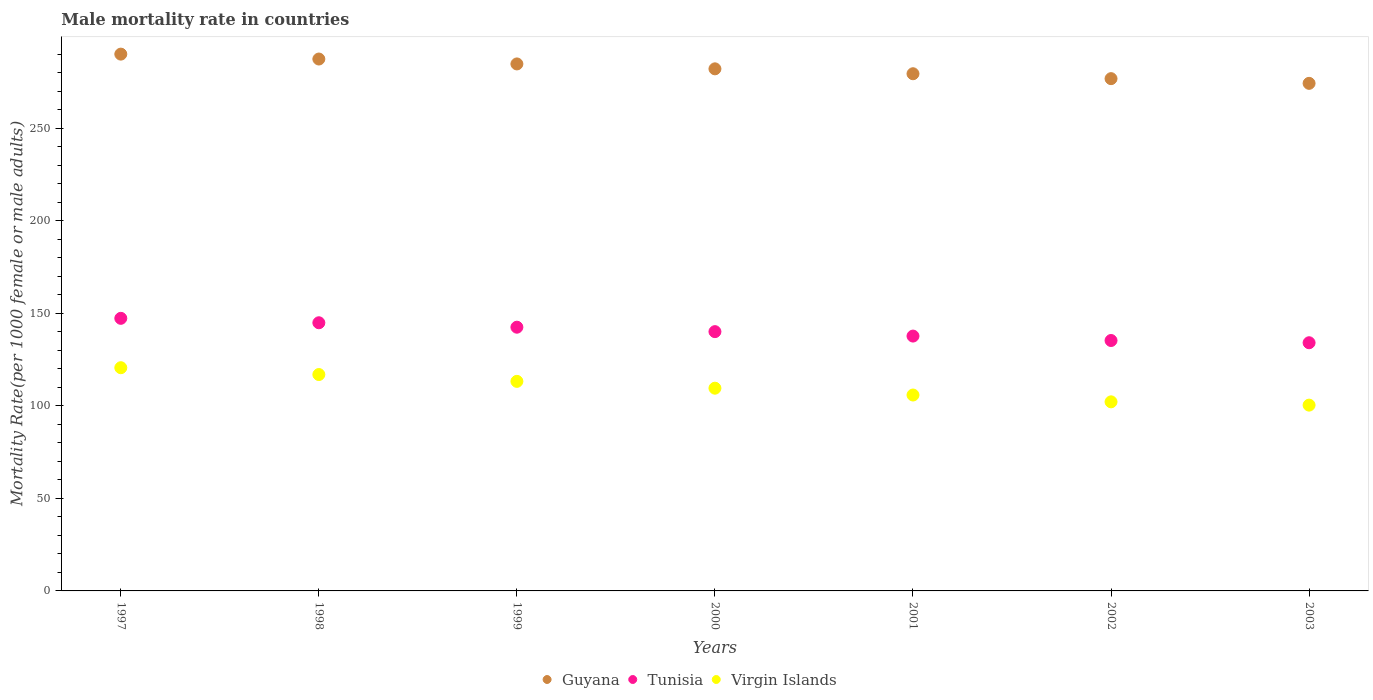How many different coloured dotlines are there?
Your answer should be compact. 3. What is the male mortality rate in Tunisia in 2001?
Give a very brief answer. 137.74. Across all years, what is the maximum male mortality rate in Guyana?
Keep it short and to the point. 290.13. Across all years, what is the minimum male mortality rate in Virgin Islands?
Ensure brevity in your answer.  100.42. What is the total male mortality rate in Guyana in the graph?
Keep it short and to the point. 1975.35. What is the difference between the male mortality rate in Virgin Islands in 2001 and that in 2002?
Make the answer very short. 3.69. What is the difference between the male mortality rate in Virgin Islands in 2002 and the male mortality rate in Tunisia in 1999?
Your answer should be compact. -40.34. What is the average male mortality rate in Virgin Islands per year?
Provide a short and direct response. 109.85. In the year 2000, what is the difference between the male mortality rate in Virgin Islands and male mortality rate in Guyana?
Keep it short and to the point. -172.6. What is the ratio of the male mortality rate in Tunisia in 1997 to that in 1999?
Give a very brief answer. 1.03. Is the male mortality rate in Virgin Islands in 2000 less than that in 2002?
Your response must be concise. No. Is the difference between the male mortality rate in Virgin Islands in 1997 and 1998 greater than the difference between the male mortality rate in Guyana in 1997 and 1998?
Ensure brevity in your answer.  Yes. What is the difference between the highest and the second highest male mortality rate in Tunisia?
Provide a short and direct response. 2.4. What is the difference between the highest and the lowest male mortality rate in Virgin Islands?
Offer a very short reply. 20.22. Is the male mortality rate in Tunisia strictly greater than the male mortality rate in Virgin Islands over the years?
Your response must be concise. Yes. Where does the legend appear in the graph?
Your response must be concise. Bottom center. What is the title of the graph?
Give a very brief answer. Male mortality rate in countries. What is the label or title of the X-axis?
Provide a succinct answer. Years. What is the label or title of the Y-axis?
Ensure brevity in your answer.  Mortality Rate(per 1000 female or male adults). What is the Mortality Rate(per 1000 female or male adults) of Guyana in 1997?
Keep it short and to the point. 290.13. What is the Mortality Rate(per 1000 female or male adults) of Tunisia in 1997?
Your response must be concise. 147.33. What is the Mortality Rate(per 1000 female or male adults) in Virgin Islands in 1997?
Keep it short and to the point. 120.64. What is the Mortality Rate(per 1000 female or male adults) in Guyana in 1998?
Your response must be concise. 287.48. What is the Mortality Rate(per 1000 female or male adults) in Tunisia in 1998?
Make the answer very short. 144.93. What is the Mortality Rate(per 1000 female or male adults) of Virgin Islands in 1998?
Keep it short and to the point. 116.95. What is the Mortality Rate(per 1000 female or male adults) in Guyana in 1999?
Your answer should be very brief. 284.83. What is the Mortality Rate(per 1000 female or male adults) in Tunisia in 1999?
Give a very brief answer. 142.54. What is the Mortality Rate(per 1000 female or male adults) in Virgin Islands in 1999?
Provide a short and direct response. 113.26. What is the Mortality Rate(per 1000 female or male adults) in Guyana in 2000?
Keep it short and to the point. 282.18. What is the Mortality Rate(per 1000 female or male adults) of Tunisia in 2000?
Offer a very short reply. 140.14. What is the Mortality Rate(per 1000 female or male adults) of Virgin Islands in 2000?
Your answer should be compact. 109.57. What is the Mortality Rate(per 1000 female or male adults) of Guyana in 2001?
Offer a terse response. 279.53. What is the Mortality Rate(per 1000 female or male adults) in Tunisia in 2001?
Your answer should be very brief. 137.74. What is the Mortality Rate(per 1000 female or male adults) of Virgin Islands in 2001?
Keep it short and to the point. 105.88. What is the Mortality Rate(per 1000 female or male adults) of Guyana in 2002?
Provide a succinct answer. 276.88. What is the Mortality Rate(per 1000 female or male adults) in Tunisia in 2002?
Offer a terse response. 135.34. What is the Mortality Rate(per 1000 female or male adults) in Virgin Islands in 2002?
Give a very brief answer. 102.19. What is the Mortality Rate(per 1000 female or male adults) of Guyana in 2003?
Your response must be concise. 274.34. What is the Mortality Rate(per 1000 female or male adults) in Tunisia in 2003?
Offer a very short reply. 134.13. What is the Mortality Rate(per 1000 female or male adults) in Virgin Islands in 2003?
Provide a succinct answer. 100.42. Across all years, what is the maximum Mortality Rate(per 1000 female or male adults) in Guyana?
Your answer should be very brief. 290.13. Across all years, what is the maximum Mortality Rate(per 1000 female or male adults) of Tunisia?
Give a very brief answer. 147.33. Across all years, what is the maximum Mortality Rate(per 1000 female or male adults) of Virgin Islands?
Make the answer very short. 120.64. Across all years, what is the minimum Mortality Rate(per 1000 female or male adults) in Guyana?
Your response must be concise. 274.34. Across all years, what is the minimum Mortality Rate(per 1000 female or male adults) of Tunisia?
Give a very brief answer. 134.13. Across all years, what is the minimum Mortality Rate(per 1000 female or male adults) of Virgin Islands?
Provide a succinct answer. 100.42. What is the total Mortality Rate(per 1000 female or male adults) in Guyana in the graph?
Provide a short and direct response. 1975.35. What is the total Mortality Rate(per 1000 female or male adults) in Tunisia in the graph?
Offer a terse response. 982.16. What is the total Mortality Rate(per 1000 female or male adults) of Virgin Islands in the graph?
Offer a very short reply. 768.92. What is the difference between the Mortality Rate(per 1000 female or male adults) of Guyana in 1997 and that in 1998?
Offer a terse response. 2.65. What is the difference between the Mortality Rate(per 1000 female or male adults) in Tunisia in 1997 and that in 1998?
Your answer should be compact. 2.4. What is the difference between the Mortality Rate(per 1000 female or male adults) of Virgin Islands in 1997 and that in 1998?
Offer a very short reply. 3.69. What is the difference between the Mortality Rate(per 1000 female or male adults) in Guyana in 1997 and that in 1999?
Offer a very short reply. 5.3. What is the difference between the Mortality Rate(per 1000 female or male adults) in Tunisia in 1997 and that in 1999?
Give a very brief answer. 4.8. What is the difference between the Mortality Rate(per 1000 female or male adults) of Virgin Islands in 1997 and that in 1999?
Give a very brief answer. 7.38. What is the difference between the Mortality Rate(per 1000 female or male adults) in Guyana in 1997 and that in 2000?
Provide a short and direct response. 7.95. What is the difference between the Mortality Rate(per 1000 female or male adults) of Tunisia in 1997 and that in 2000?
Offer a very short reply. 7.19. What is the difference between the Mortality Rate(per 1000 female or male adults) in Virgin Islands in 1997 and that in 2000?
Make the answer very short. 11.07. What is the difference between the Mortality Rate(per 1000 female or male adults) of Guyana in 1997 and that in 2001?
Ensure brevity in your answer.  10.6. What is the difference between the Mortality Rate(per 1000 female or male adults) in Tunisia in 1997 and that in 2001?
Your answer should be very brief. 9.59. What is the difference between the Mortality Rate(per 1000 female or male adults) of Virgin Islands in 1997 and that in 2001?
Make the answer very short. 14.76. What is the difference between the Mortality Rate(per 1000 female or male adults) of Guyana in 1997 and that in 2002?
Make the answer very short. 13.26. What is the difference between the Mortality Rate(per 1000 female or male adults) in Tunisia in 1997 and that in 2002?
Give a very brief answer. 11.99. What is the difference between the Mortality Rate(per 1000 female or male adults) of Virgin Islands in 1997 and that in 2002?
Offer a terse response. 18.45. What is the difference between the Mortality Rate(per 1000 female or male adults) in Guyana in 1997 and that in 2003?
Offer a very short reply. 15.79. What is the difference between the Mortality Rate(per 1000 female or male adults) in Tunisia in 1997 and that in 2003?
Give a very brief answer. 13.2. What is the difference between the Mortality Rate(per 1000 female or male adults) in Virgin Islands in 1997 and that in 2003?
Make the answer very short. 20.22. What is the difference between the Mortality Rate(per 1000 female or male adults) in Guyana in 1998 and that in 1999?
Your answer should be very brief. 2.65. What is the difference between the Mortality Rate(per 1000 female or male adults) in Tunisia in 1998 and that in 1999?
Offer a very short reply. 2.4. What is the difference between the Mortality Rate(per 1000 female or male adults) of Virgin Islands in 1998 and that in 1999?
Your answer should be compact. 3.69. What is the difference between the Mortality Rate(per 1000 female or male adults) of Guyana in 1998 and that in 2000?
Make the answer very short. 5.3. What is the difference between the Mortality Rate(per 1000 female or male adults) in Tunisia in 1998 and that in 2000?
Keep it short and to the point. 4.8. What is the difference between the Mortality Rate(per 1000 female or male adults) in Virgin Islands in 1998 and that in 2000?
Give a very brief answer. 7.38. What is the difference between the Mortality Rate(per 1000 female or male adults) in Guyana in 1998 and that in 2001?
Offer a very short reply. 7.95. What is the difference between the Mortality Rate(per 1000 female or male adults) in Tunisia in 1998 and that in 2001?
Keep it short and to the point. 7.19. What is the difference between the Mortality Rate(per 1000 female or male adults) of Virgin Islands in 1998 and that in 2001?
Offer a very short reply. 11.07. What is the difference between the Mortality Rate(per 1000 female or male adults) of Guyana in 1998 and that in 2002?
Your response must be concise. 10.6. What is the difference between the Mortality Rate(per 1000 female or male adults) in Tunisia in 1998 and that in 2002?
Provide a succinct answer. 9.59. What is the difference between the Mortality Rate(per 1000 female or male adults) in Virgin Islands in 1998 and that in 2002?
Offer a very short reply. 14.76. What is the difference between the Mortality Rate(per 1000 female or male adults) in Guyana in 1998 and that in 2003?
Your answer should be very brief. 13.14. What is the difference between the Mortality Rate(per 1000 female or male adults) in Tunisia in 1998 and that in 2003?
Provide a succinct answer. 10.8. What is the difference between the Mortality Rate(per 1000 female or male adults) of Virgin Islands in 1998 and that in 2003?
Offer a very short reply. 16.53. What is the difference between the Mortality Rate(per 1000 female or male adults) of Guyana in 1999 and that in 2000?
Keep it short and to the point. 2.65. What is the difference between the Mortality Rate(per 1000 female or male adults) in Tunisia in 1999 and that in 2000?
Your response must be concise. 2.4. What is the difference between the Mortality Rate(per 1000 female or male adults) in Virgin Islands in 1999 and that in 2000?
Provide a short and direct response. 3.69. What is the difference between the Mortality Rate(per 1000 female or male adults) in Guyana in 1999 and that in 2001?
Provide a short and direct response. 5.3. What is the difference between the Mortality Rate(per 1000 female or male adults) in Tunisia in 1999 and that in 2001?
Provide a short and direct response. 4.8. What is the difference between the Mortality Rate(per 1000 female or male adults) of Virgin Islands in 1999 and that in 2001?
Keep it short and to the point. 7.38. What is the difference between the Mortality Rate(per 1000 female or male adults) in Guyana in 1999 and that in 2002?
Keep it short and to the point. 7.95. What is the difference between the Mortality Rate(per 1000 female or male adults) of Tunisia in 1999 and that in 2002?
Your response must be concise. 7.19. What is the difference between the Mortality Rate(per 1000 female or male adults) in Virgin Islands in 1999 and that in 2002?
Give a very brief answer. 11.07. What is the difference between the Mortality Rate(per 1000 female or male adults) in Guyana in 1999 and that in 2003?
Offer a very short reply. 10.49. What is the difference between the Mortality Rate(per 1000 female or male adults) of Tunisia in 1999 and that in 2003?
Provide a succinct answer. 8.4. What is the difference between the Mortality Rate(per 1000 female or male adults) in Virgin Islands in 1999 and that in 2003?
Make the answer very short. 12.84. What is the difference between the Mortality Rate(per 1000 female or male adults) in Guyana in 2000 and that in 2001?
Your answer should be compact. 2.65. What is the difference between the Mortality Rate(per 1000 female or male adults) in Tunisia in 2000 and that in 2001?
Offer a very short reply. 2.4. What is the difference between the Mortality Rate(per 1000 female or male adults) of Virgin Islands in 2000 and that in 2001?
Provide a succinct answer. 3.69. What is the difference between the Mortality Rate(per 1000 female or male adults) of Guyana in 2000 and that in 2002?
Provide a succinct answer. 5.3. What is the difference between the Mortality Rate(per 1000 female or male adults) in Tunisia in 2000 and that in 2002?
Offer a very short reply. 4.8. What is the difference between the Mortality Rate(per 1000 female or male adults) in Virgin Islands in 2000 and that in 2002?
Provide a short and direct response. 7.38. What is the difference between the Mortality Rate(per 1000 female or male adults) in Guyana in 2000 and that in 2003?
Ensure brevity in your answer.  7.84. What is the difference between the Mortality Rate(per 1000 female or male adults) of Tunisia in 2000 and that in 2003?
Make the answer very short. 6. What is the difference between the Mortality Rate(per 1000 female or male adults) of Virgin Islands in 2000 and that in 2003?
Your response must be concise. 9.15. What is the difference between the Mortality Rate(per 1000 female or male adults) of Guyana in 2001 and that in 2002?
Make the answer very short. 2.65. What is the difference between the Mortality Rate(per 1000 female or male adults) in Tunisia in 2001 and that in 2002?
Give a very brief answer. 2.4. What is the difference between the Mortality Rate(per 1000 female or male adults) of Virgin Islands in 2001 and that in 2002?
Your answer should be compact. 3.69. What is the difference between the Mortality Rate(per 1000 female or male adults) in Guyana in 2001 and that in 2003?
Give a very brief answer. 5.19. What is the difference between the Mortality Rate(per 1000 female or male adults) of Tunisia in 2001 and that in 2003?
Offer a terse response. 3.61. What is the difference between the Mortality Rate(per 1000 female or male adults) in Virgin Islands in 2001 and that in 2003?
Your answer should be compact. 5.46. What is the difference between the Mortality Rate(per 1000 female or male adults) of Guyana in 2002 and that in 2003?
Offer a very short reply. 2.54. What is the difference between the Mortality Rate(per 1000 female or male adults) of Tunisia in 2002 and that in 2003?
Offer a very short reply. 1.21. What is the difference between the Mortality Rate(per 1000 female or male adults) of Virgin Islands in 2002 and that in 2003?
Ensure brevity in your answer.  1.77. What is the difference between the Mortality Rate(per 1000 female or male adults) of Guyana in 1997 and the Mortality Rate(per 1000 female or male adults) of Tunisia in 1998?
Your answer should be compact. 145.2. What is the difference between the Mortality Rate(per 1000 female or male adults) of Guyana in 1997 and the Mortality Rate(per 1000 female or male adults) of Virgin Islands in 1998?
Your answer should be very brief. 173.18. What is the difference between the Mortality Rate(per 1000 female or male adults) of Tunisia in 1997 and the Mortality Rate(per 1000 female or male adults) of Virgin Islands in 1998?
Your response must be concise. 30.38. What is the difference between the Mortality Rate(per 1000 female or male adults) in Guyana in 1997 and the Mortality Rate(per 1000 female or male adults) in Tunisia in 1999?
Provide a succinct answer. 147.59. What is the difference between the Mortality Rate(per 1000 female or male adults) in Guyana in 1997 and the Mortality Rate(per 1000 female or male adults) in Virgin Islands in 1999?
Keep it short and to the point. 176.87. What is the difference between the Mortality Rate(per 1000 female or male adults) of Tunisia in 1997 and the Mortality Rate(per 1000 female or male adults) of Virgin Islands in 1999?
Ensure brevity in your answer.  34.07. What is the difference between the Mortality Rate(per 1000 female or male adults) in Guyana in 1997 and the Mortality Rate(per 1000 female or male adults) in Tunisia in 2000?
Provide a short and direct response. 149.99. What is the difference between the Mortality Rate(per 1000 female or male adults) in Guyana in 1997 and the Mortality Rate(per 1000 female or male adults) in Virgin Islands in 2000?
Keep it short and to the point. 180.56. What is the difference between the Mortality Rate(per 1000 female or male adults) in Tunisia in 1997 and the Mortality Rate(per 1000 female or male adults) in Virgin Islands in 2000?
Give a very brief answer. 37.76. What is the difference between the Mortality Rate(per 1000 female or male adults) in Guyana in 1997 and the Mortality Rate(per 1000 female or male adults) in Tunisia in 2001?
Make the answer very short. 152.39. What is the difference between the Mortality Rate(per 1000 female or male adults) in Guyana in 1997 and the Mortality Rate(per 1000 female or male adults) in Virgin Islands in 2001?
Keep it short and to the point. 184.25. What is the difference between the Mortality Rate(per 1000 female or male adults) of Tunisia in 1997 and the Mortality Rate(per 1000 female or male adults) of Virgin Islands in 2001?
Provide a short and direct response. 41.45. What is the difference between the Mortality Rate(per 1000 female or male adults) in Guyana in 1997 and the Mortality Rate(per 1000 female or male adults) in Tunisia in 2002?
Ensure brevity in your answer.  154.79. What is the difference between the Mortality Rate(per 1000 female or male adults) of Guyana in 1997 and the Mortality Rate(per 1000 female or male adults) of Virgin Islands in 2002?
Make the answer very short. 187.94. What is the difference between the Mortality Rate(per 1000 female or male adults) in Tunisia in 1997 and the Mortality Rate(per 1000 female or male adults) in Virgin Islands in 2002?
Ensure brevity in your answer.  45.14. What is the difference between the Mortality Rate(per 1000 female or male adults) in Guyana in 1997 and the Mortality Rate(per 1000 female or male adults) in Tunisia in 2003?
Ensure brevity in your answer.  156. What is the difference between the Mortality Rate(per 1000 female or male adults) in Guyana in 1997 and the Mortality Rate(per 1000 female or male adults) in Virgin Islands in 2003?
Provide a succinct answer. 189.71. What is the difference between the Mortality Rate(per 1000 female or male adults) of Tunisia in 1997 and the Mortality Rate(per 1000 female or male adults) of Virgin Islands in 2003?
Give a very brief answer. 46.91. What is the difference between the Mortality Rate(per 1000 female or male adults) in Guyana in 1998 and the Mortality Rate(per 1000 female or male adults) in Tunisia in 1999?
Offer a terse response. 144.94. What is the difference between the Mortality Rate(per 1000 female or male adults) of Guyana in 1998 and the Mortality Rate(per 1000 female or male adults) of Virgin Islands in 1999?
Make the answer very short. 174.22. What is the difference between the Mortality Rate(per 1000 female or male adults) of Tunisia in 1998 and the Mortality Rate(per 1000 female or male adults) of Virgin Islands in 1999?
Offer a very short reply. 31.67. What is the difference between the Mortality Rate(per 1000 female or male adults) in Guyana in 1998 and the Mortality Rate(per 1000 female or male adults) in Tunisia in 2000?
Give a very brief answer. 147.34. What is the difference between the Mortality Rate(per 1000 female or male adults) in Guyana in 1998 and the Mortality Rate(per 1000 female or male adults) in Virgin Islands in 2000?
Provide a short and direct response. 177.91. What is the difference between the Mortality Rate(per 1000 female or male adults) of Tunisia in 1998 and the Mortality Rate(per 1000 female or male adults) of Virgin Islands in 2000?
Keep it short and to the point. 35.36. What is the difference between the Mortality Rate(per 1000 female or male adults) in Guyana in 1998 and the Mortality Rate(per 1000 female or male adults) in Tunisia in 2001?
Offer a terse response. 149.74. What is the difference between the Mortality Rate(per 1000 female or male adults) in Guyana in 1998 and the Mortality Rate(per 1000 female or male adults) in Virgin Islands in 2001?
Your answer should be compact. 181.6. What is the difference between the Mortality Rate(per 1000 female or male adults) of Tunisia in 1998 and the Mortality Rate(per 1000 female or male adults) of Virgin Islands in 2001?
Provide a succinct answer. 39.05. What is the difference between the Mortality Rate(per 1000 female or male adults) of Guyana in 1998 and the Mortality Rate(per 1000 female or male adults) of Tunisia in 2002?
Provide a succinct answer. 152.14. What is the difference between the Mortality Rate(per 1000 female or male adults) of Guyana in 1998 and the Mortality Rate(per 1000 female or male adults) of Virgin Islands in 2002?
Provide a short and direct response. 185.28. What is the difference between the Mortality Rate(per 1000 female or male adults) of Tunisia in 1998 and the Mortality Rate(per 1000 female or male adults) of Virgin Islands in 2002?
Keep it short and to the point. 42.74. What is the difference between the Mortality Rate(per 1000 female or male adults) of Guyana in 1998 and the Mortality Rate(per 1000 female or male adults) of Tunisia in 2003?
Your answer should be compact. 153.34. What is the difference between the Mortality Rate(per 1000 female or male adults) of Guyana in 1998 and the Mortality Rate(per 1000 female or male adults) of Virgin Islands in 2003?
Offer a very short reply. 187.06. What is the difference between the Mortality Rate(per 1000 female or male adults) in Tunisia in 1998 and the Mortality Rate(per 1000 female or male adults) in Virgin Islands in 2003?
Provide a succinct answer. 44.51. What is the difference between the Mortality Rate(per 1000 female or male adults) in Guyana in 1999 and the Mortality Rate(per 1000 female or male adults) in Tunisia in 2000?
Ensure brevity in your answer.  144.69. What is the difference between the Mortality Rate(per 1000 female or male adults) of Guyana in 1999 and the Mortality Rate(per 1000 female or male adults) of Virgin Islands in 2000?
Your response must be concise. 175.26. What is the difference between the Mortality Rate(per 1000 female or male adults) of Tunisia in 1999 and the Mortality Rate(per 1000 female or male adults) of Virgin Islands in 2000?
Offer a terse response. 32.96. What is the difference between the Mortality Rate(per 1000 female or male adults) in Guyana in 1999 and the Mortality Rate(per 1000 female or male adults) in Tunisia in 2001?
Offer a very short reply. 147.09. What is the difference between the Mortality Rate(per 1000 female or male adults) of Guyana in 1999 and the Mortality Rate(per 1000 female or male adults) of Virgin Islands in 2001?
Give a very brief answer. 178.94. What is the difference between the Mortality Rate(per 1000 female or male adults) of Tunisia in 1999 and the Mortality Rate(per 1000 female or male adults) of Virgin Islands in 2001?
Provide a succinct answer. 36.65. What is the difference between the Mortality Rate(per 1000 female or male adults) in Guyana in 1999 and the Mortality Rate(per 1000 female or male adults) in Tunisia in 2002?
Provide a short and direct response. 149.49. What is the difference between the Mortality Rate(per 1000 female or male adults) of Guyana in 1999 and the Mortality Rate(per 1000 female or male adults) of Virgin Islands in 2002?
Your answer should be very brief. 182.63. What is the difference between the Mortality Rate(per 1000 female or male adults) in Tunisia in 1999 and the Mortality Rate(per 1000 female or male adults) in Virgin Islands in 2002?
Make the answer very short. 40.34. What is the difference between the Mortality Rate(per 1000 female or male adults) of Guyana in 1999 and the Mortality Rate(per 1000 female or male adults) of Tunisia in 2003?
Your response must be concise. 150.69. What is the difference between the Mortality Rate(per 1000 female or male adults) in Guyana in 1999 and the Mortality Rate(per 1000 female or male adults) in Virgin Islands in 2003?
Offer a very short reply. 184.41. What is the difference between the Mortality Rate(per 1000 female or male adults) in Tunisia in 1999 and the Mortality Rate(per 1000 female or male adults) in Virgin Islands in 2003?
Your answer should be very brief. 42.12. What is the difference between the Mortality Rate(per 1000 female or male adults) of Guyana in 2000 and the Mortality Rate(per 1000 female or male adults) of Tunisia in 2001?
Offer a terse response. 144.44. What is the difference between the Mortality Rate(per 1000 female or male adults) in Guyana in 2000 and the Mortality Rate(per 1000 female or male adults) in Virgin Islands in 2001?
Provide a short and direct response. 176.29. What is the difference between the Mortality Rate(per 1000 female or male adults) in Tunisia in 2000 and the Mortality Rate(per 1000 female or male adults) in Virgin Islands in 2001?
Ensure brevity in your answer.  34.25. What is the difference between the Mortality Rate(per 1000 female or male adults) in Guyana in 2000 and the Mortality Rate(per 1000 female or male adults) in Tunisia in 2002?
Your answer should be very brief. 146.84. What is the difference between the Mortality Rate(per 1000 female or male adults) in Guyana in 2000 and the Mortality Rate(per 1000 female or male adults) in Virgin Islands in 2002?
Provide a short and direct response. 179.98. What is the difference between the Mortality Rate(per 1000 female or male adults) in Tunisia in 2000 and the Mortality Rate(per 1000 female or male adults) in Virgin Islands in 2002?
Your answer should be very brief. 37.94. What is the difference between the Mortality Rate(per 1000 female or male adults) of Guyana in 2000 and the Mortality Rate(per 1000 female or male adults) of Tunisia in 2003?
Your answer should be very brief. 148.04. What is the difference between the Mortality Rate(per 1000 female or male adults) in Guyana in 2000 and the Mortality Rate(per 1000 female or male adults) in Virgin Islands in 2003?
Your answer should be compact. 181.76. What is the difference between the Mortality Rate(per 1000 female or male adults) of Tunisia in 2000 and the Mortality Rate(per 1000 female or male adults) of Virgin Islands in 2003?
Give a very brief answer. 39.72. What is the difference between the Mortality Rate(per 1000 female or male adults) in Guyana in 2001 and the Mortality Rate(per 1000 female or male adults) in Tunisia in 2002?
Your answer should be compact. 144.18. What is the difference between the Mortality Rate(per 1000 female or male adults) in Guyana in 2001 and the Mortality Rate(per 1000 female or male adults) in Virgin Islands in 2002?
Your answer should be compact. 177.33. What is the difference between the Mortality Rate(per 1000 female or male adults) of Tunisia in 2001 and the Mortality Rate(per 1000 female or male adults) of Virgin Islands in 2002?
Give a very brief answer. 35.55. What is the difference between the Mortality Rate(per 1000 female or male adults) of Guyana in 2001 and the Mortality Rate(per 1000 female or male adults) of Tunisia in 2003?
Provide a short and direct response. 145.39. What is the difference between the Mortality Rate(per 1000 female or male adults) of Guyana in 2001 and the Mortality Rate(per 1000 female or male adults) of Virgin Islands in 2003?
Provide a succinct answer. 179.11. What is the difference between the Mortality Rate(per 1000 female or male adults) in Tunisia in 2001 and the Mortality Rate(per 1000 female or male adults) in Virgin Islands in 2003?
Offer a very short reply. 37.32. What is the difference between the Mortality Rate(per 1000 female or male adults) in Guyana in 2002 and the Mortality Rate(per 1000 female or male adults) in Tunisia in 2003?
Offer a terse response. 142.74. What is the difference between the Mortality Rate(per 1000 female or male adults) of Guyana in 2002 and the Mortality Rate(per 1000 female or male adults) of Virgin Islands in 2003?
Make the answer very short. 176.46. What is the difference between the Mortality Rate(per 1000 female or male adults) of Tunisia in 2002 and the Mortality Rate(per 1000 female or male adults) of Virgin Islands in 2003?
Provide a succinct answer. 34.92. What is the average Mortality Rate(per 1000 female or male adults) in Guyana per year?
Offer a very short reply. 282.19. What is the average Mortality Rate(per 1000 female or male adults) of Tunisia per year?
Ensure brevity in your answer.  140.31. What is the average Mortality Rate(per 1000 female or male adults) in Virgin Islands per year?
Your answer should be compact. 109.85. In the year 1997, what is the difference between the Mortality Rate(per 1000 female or male adults) in Guyana and Mortality Rate(per 1000 female or male adults) in Tunisia?
Ensure brevity in your answer.  142.8. In the year 1997, what is the difference between the Mortality Rate(per 1000 female or male adults) in Guyana and Mortality Rate(per 1000 female or male adults) in Virgin Islands?
Provide a short and direct response. 169.49. In the year 1997, what is the difference between the Mortality Rate(per 1000 female or male adults) of Tunisia and Mortality Rate(per 1000 female or male adults) of Virgin Islands?
Your answer should be compact. 26.69. In the year 1998, what is the difference between the Mortality Rate(per 1000 female or male adults) in Guyana and Mortality Rate(per 1000 female or male adults) in Tunisia?
Provide a succinct answer. 142.54. In the year 1998, what is the difference between the Mortality Rate(per 1000 female or male adults) of Guyana and Mortality Rate(per 1000 female or male adults) of Virgin Islands?
Offer a terse response. 170.53. In the year 1998, what is the difference between the Mortality Rate(per 1000 female or male adults) in Tunisia and Mortality Rate(per 1000 female or male adults) in Virgin Islands?
Keep it short and to the point. 27.98. In the year 1999, what is the difference between the Mortality Rate(per 1000 female or male adults) of Guyana and Mortality Rate(per 1000 female or male adults) of Tunisia?
Your response must be concise. 142.29. In the year 1999, what is the difference between the Mortality Rate(per 1000 female or male adults) of Guyana and Mortality Rate(per 1000 female or male adults) of Virgin Islands?
Your answer should be very brief. 171.57. In the year 1999, what is the difference between the Mortality Rate(per 1000 female or male adults) of Tunisia and Mortality Rate(per 1000 female or male adults) of Virgin Islands?
Make the answer very short. 29.27. In the year 2000, what is the difference between the Mortality Rate(per 1000 female or male adults) of Guyana and Mortality Rate(per 1000 female or male adults) of Tunisia?
Ensure brevity in your answer.  142.04. In the year 2000, what is the difference between the Mortality Rate(per 1000 female or male adults) of Guyana and Mortality Rate(per 1000 female or male adults) of Virgin Islands?
Your response must be concise. 172.6. In the year 2000, what is the difference between the Mortality Rate(per 1000 female or male adults) of Tunisia and Mortality Rate(per 1000 female or male adults) of Virgin Islands?
Make the answer very short. 30.57. In the year 2001, what is the difference between the Mortality Rate(per 1000 female or male adults) of Guyana and Mortality Rate(per 1000 female or male adults) of Tunisia?
Provide a succinct answer. 141.79. In the year 2001, what is the difference between the Mortality Rate(per 1000 female or male adults) in Guyana and Mortality Rate(per 1000 female or male adults) in Virgin Islands?
Make the answer very short. 173.64. In the year 2001, what is the difference between the Mortality Rate(per 1000 female or male adults) in Tunisia and Mortality Rate(per 1000 female or male adults) in Virgin Islands?
Keep it short and to the point. 31.86. In the year 2002, what is the difference between the Mortality Rate(per 1000 female or male adults) of Guyana and Mortality Rate(per 1000 female or male adults) of Tunisia?
Your answer should be very brief. 141.53. In the year 2002, what is the difference between the Mortality Rate(per 1000 female or male adults) in Guyana and Mortality Rate(per 1000 female or male adults) in Virgin Islands?
Offer a very short reply. 174.68. In the year 2002, what is the difference between the Mortality Rate(per 1000 female or male adults) in Tunisia and Mortality Rate(per 1000 female or male adults) in Virgin Islands?
Offer a terse response. 33.15. In the year 2003, what is the difference between the Mortality Rate(per 1000 female or male adults) of Guyana and Mortality Rate(per 1000 female or male adults) of Tunisia?
Give a very brief answer. 140.2. In the year 2003, what is the difference between the Mortality Rate(per 1000 female or male adults) of Guyana and Mortality Rate(per 1000 female or male adults) of Virgin Islands?
Provide a succinct answer. 173.92. In the year 2003, what is the difference between the Mortality Rate(per 1000 female or male adults) in Tunisia and Mortality Rate(per 1000 female or male adults) in Virgin Islands?
Your answer should be very brief. 33.71. What is the ratio of the Mortality Rate(per 1000 female or male adults) in Guyana in 1997 to that in 1998?
Provide a short and direct response. 1.01. What is the ratio of the Mortality Rate(per 1000 female or male adults) in Tunisia in 1997 to that in 1998?
Keep it short and to the point. 1.02. What is the ratio of the Mortality Rate(per 1000 female or male adults) in Virgin Islands in 1997 to that in 1998?
Your answer should be compact. 1.03. What is the ratio of the Mortality Rate(per 1000 female or male adults) in Guyana in 1997 to that in 1999?
Provide a succinct answer. 1.02. What is the ratio of the Mortality Rate(per 1000 female or male adults) in Tunisia in 1997 to that in 1999?
Your answer should be compact. 1.03. What is the ratio of the Mortality Rate(per 1000 female or male adults) of Virgin Islands in 1997 to that in 1999?
Provide a succinct answer. 1.07. What is the ratio of the Mortality Rate(per 1000 female or male adults) of Guyana in 1997 to that in 2000?
Provide a succinct answer. 1.03. What is the ratio of the Mortality Rate(per 1000 female or male adults) of Tunisia in 1997 to that in 2000?
Offer a very short reply. 1.05. What is the ratio of the Mortality Rate(per 1000 female or male adults) in Virgin Islands in 1997 to that in 2000?
Offer a terse response. 1.1. What is the ratio of the Mortality Rate(per 1000 female or male adults) of Guyana in 1997 to that in 2001?
Ensure brevity in your answer.  1.04. What is the ratio of the Mortality Rate(per 1000 female or male adults) of Tunisia in 1997 to that in 2001?
Give a very brief answer. 1.07. What is the ratio of the Mortality Rate(per 1000 female or male adults) in Virgin Islands in 1997 to that in 2001?
Provide a succinct answer. 1.14. What is the ratio of the Mortality Rate(per 1000 female or male adults) of Guyana in 1997 to that in 2002?
Your response must be concise. 1.05. What is the ratio of the Mortality Rate(per 1000 female or male adults) in Tunisia in 1997 to that in 2002?
Provide a short and direct response. 1.09. What is the ratio of the Mortality Rate(per 1000 female or male adults) in Virgin Islands in 1997 to that in 2002?
Provide a short and direct response. 1.18. What is the ratio of the Mortality Rate(per 1000 female or male adults) in Guyana in 1997 to that in 2003?
Keep it short and to the point. 1.06. What is the ratio of the Mortality Rate(per 1000 female or male adults) in Tunisia in 1997 to that in 2003?
Your response must be concise. 1.1. What is the ratio of the Mortality Rate(per 1000 female or male adults) of Virgin Islands in 1997 to that in 2003?
Provide a short and direct response. 1.2. What is the ratio of the Mortality Rate(per 1000 female or male adults) of Guyana in 1998 to that in 1999?
Give a very brief answer. 1.01. What is the ratio of the Mortality Rate(per 1000 female or male adults) of Tunisia in 1998 to that in 1999?
Offer a terse response. 1.02. What is the ratio of the Mortality Rate(per 1000 female or male adults) in Virgin Islands in 1998 to that in 1999?
Ensure brevity in your answer.  1.03. What is the ratio of the Mortality Rate(per 1000 female or male adults) in Guyana in 1998 to that in 2000?
Give a very brief answer. 1.02. What is the ratio of the Mortality Rate(per 1000 female or male adults) of Tunisia in 1998 to that in 2000?
Your answer should be compact. 1.03. What is the ratio of the Mortality Rate(per 1000 female or male adults) in Virgin Islands in 1998 to that in 2000?
Ensure brevity in your answer.  1.07. What is the ratio of the Mortality Rate(per 1000 female or male adults) in Guyana in 1998 to that in 2001?
Ensure brevity in your answer.  1.03. What is the ratio of the Mortality Rate(per 1000 female or male adults) of Tunisia in 1998 to that in 2001?
Your answer should be compact. 1.05. What is the ratio of the Mortality Rate(per 1000 female or male adults) of Virgin Islands in 1998 to that in 2001?
Keep it short and to the point. 1.1. What is the ratio of the Mortality Rate(per 1000 female or male adults) in Guyana in 1998 to that in 2002?
Provide a short and direct response. 1.04. What is the ratio of the Mortality Rate(per 1000 female or male adults) in Tunisia in 1998 to that in 2002?
Ensure brevity in your answer.  1.07. What is the ratio of the Mortality Rate(per 1000 female or male adults) in Virgin Islands in 1998 to that in 2002?
Your answer should be very brief. 1.14. What is the ratio of the Mortality Rate(per 1000 female or male adults) of Guyana in 1998 to that in 2003?
Ensure brevity in your answer.  1.05. What is the ratio of the Mortality Rate(per 1000 female or male adults) of Tunisia in 1998 to that in 2003?
Your answer should be compact. 1.08. What is the ratio of the Mortality Rate(per 1000 female or male adults) in Virgin Islands in 1998 to that in 2003?
Provide a succinct answer. 1.16. What is the ratio of the Mortality Rate(per 1000 female or male adults) of Guyana in 1999 to that in 2000?
Offer a very short reply. 1.01. What is the ratio of the Mortality Rate(per 1000 female or male adults) of Tunisia in 1999 to that in 2000?
Your response must be concise. 1.02. What is the ratio of the Mortality Rate(per 1000 female or male adults) of Virgin Islands in 1999 to that in 2000?
Offer a terse response. 1.03. What is the ratio of the Mortality Rate(per 1000 female or male adults) in Guyana in 1999 to that in 2001?
Give a very brief answer. 1.02. What is the ratio of the Mortality Rate(per 1000 female or male adults) of Tunisia in 1999 to that in 2001?
Provide a short and direct response. 1.03. What is the ratio of the Mortality Rate(per 1000 female or male adults) of Virgin Islands in 1999 to that in 2001?
Keep it short and to the point. 1.07. What is the ratio of the Mortality Rate(per 1000 female or male adults) in Guyana in 1999 to that in 2002?
Ensure brevity in your answer.  1.03. What is the ratio of the Mortality Rate(per 1000 female or male adults) in Tunisia in 1999 to that in 2002?
Your answer should be very brief. 1.05. What is the ratio of the Mortality Rate(per 1000 female or male adults) in Virgin Islands in 1999 to that in 2002?
Offer a terse response. 1.11. What is the ratio of the Mortality Rate(per 1000 female or male adults) of Guyana in 1999 to that in 2003?
Provide a short and direct response. 1.04. What is the ratio of the Mortality Rate(per 1000 female or male adults) of Tunisia in 1999 to that in 2003?
Your answer should be compact. 1.06. What is the ratio of the Mortality Rate(per 1000 female or male adults) in Virgin Islands in 1999 to that in 2003?
Provide a succinct answer. 1.13. What is the ratio of the Mortality Rate(per 1000 female or male adults) in Guyana in 2000 to that in 2001?
Your response must be concise. 1.01. What is the ratio of the Mortality Rate(per 1000 female or male adults) in Tunisia in 2000 to that in 2001?
Keep it short and to the point. 1.02. What is the ratio of the Mortality Rate(per 1000 female or male adults) of Virgin Islands in 2000 to that in 2001?
Make the answer very short. 1.03. What is the ratio of the Mortality Rate(per 1000 female or male adults) in Guyana in 2000 to that in 2002?
Your response must be concise. 1.02. What is the ratio of the Mortality Rate(per 1000 female or male adults) of Tunisia in 2000 to that in 2002?
Offer a terse response. 1.04. What is the ratio of the Mortality Rate(per 1000 female or male adults) in Virgin Islands in 2000 to that in 2002?
Offer a very short reply. 1.07. What is the ratio of the Mortality Rate(per 1000 female or male adults) in Guyana in 2000 to that in 2003?
Offer a terse response. 1.03. What is the ratio of the Mortality Rate(per 1000 female or male adults) of Tunisia in 2000 to that in 2003?
Give a very brief answer. 1.04. What is the ratio of the Mortality Rate(per 1000 female or male adults) of Virgin Islands in 2000 to that in 2003?
Keep it short and to the point. 1.09. What is the ratio of the Mortality Rate(per 1000 female or male adults) of Guyana in 2001 to that in 2002?
Provide a succinct answer. 1.01. What is the ratio of the Mortality Rate(per 1000 female or male adults) in Tunisia in 2001 to that in 2002?
Offer a terse response. 1.02. What is the ratio of the Mortality Rate(per 1000 female or male adults) of Virgin Islands in 2001 to that in 2002?
Offer a very short reply. 1.04. What is the ratio of the Mortality Rate(per 1000 female or male adults) of Guyana in 2001 to that in 2003?
Give a very brief answer. 1.02. What is the ratio of the Mortality Rate(per 1000 female or male adults) of Tunisia in 2001 to that in 2003?
Ensure brevity in your answer.  1.03. What is the ratio of the Mortality Rate(per 1000 female or male adults) of Virgin Islands in 2001 to that in 2003?
Provide a succinct answer. 1.05. What is the ratio of the Mortality Rate(per 1000 female or male adults) in Guyana in 2002 to that in 2003?
Your answer should be very brief. 1.01. What is the ratio of the Mortality Rate(per 1000 female or male adults) in Tunisia in 2002 to that in 2003?
Ensure brevity in your answer.  1.01. What is the ratio of the Mortality Rate(per 1000 female or male adults) in Virgin Islands in 2002 to that in 2003?
Provide a short and direct response. 1.02. What is the difference between the highest and the second highest Mortality Rate(per 1000 female or male adults) in Guyana?
Ensure brevity in your answer.  2.65. What is the difference between the highest and the second highest Mortality Rate(per 1000 female or male adults) of Tunisia?
Give a very brief answer. 2.4. What is the difference between the highest and the second highest Mortality Rate(per 1000 female or male adults) of Virgin Islands?
Offer a terse response. 3.69. What is the difference between the highest and the lowest Mortality Rate(per 1000 female or male adults) of Guyana?
Ensure brevity in your answer.  15.79. What is the difference between the highest and the lowest Mortality Rate(per 1000 female or male adults) in Tunisia?
Offer a very short reply. 13.2. What is the difference between the highest and the lowest Mortality Rate(per 1000 female or male adults) in Virgin Islands?
Offer a terse response. 20.22. 